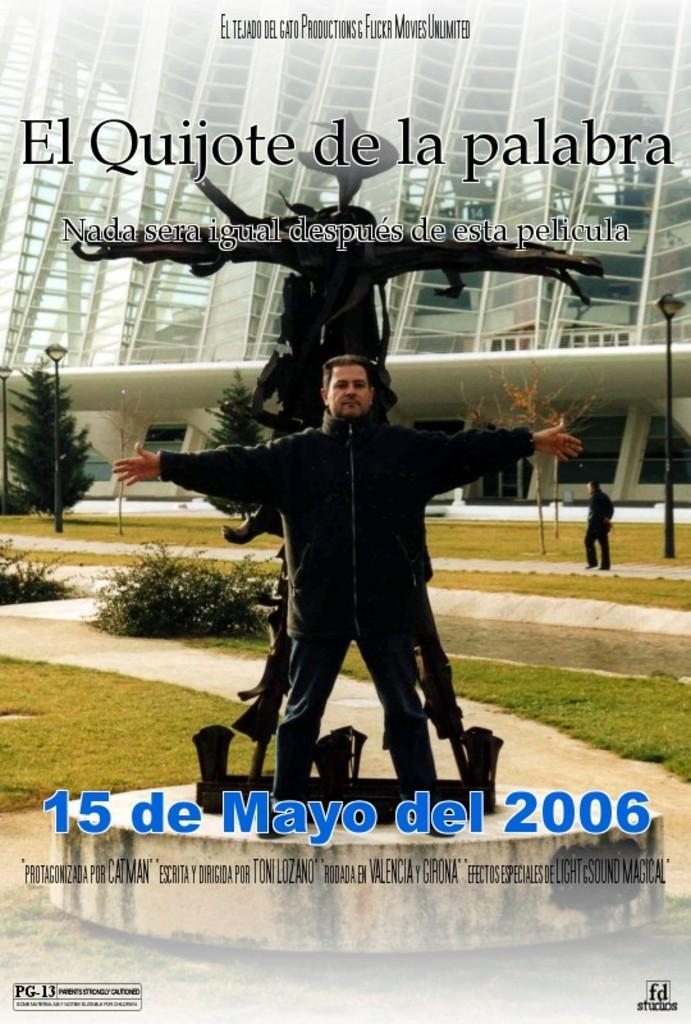<image>
Offer a succinct explanation of the picture presented. A movie poster promotes El Quijote de la Palabra, which was released on 15 de Mayo del 2006. 